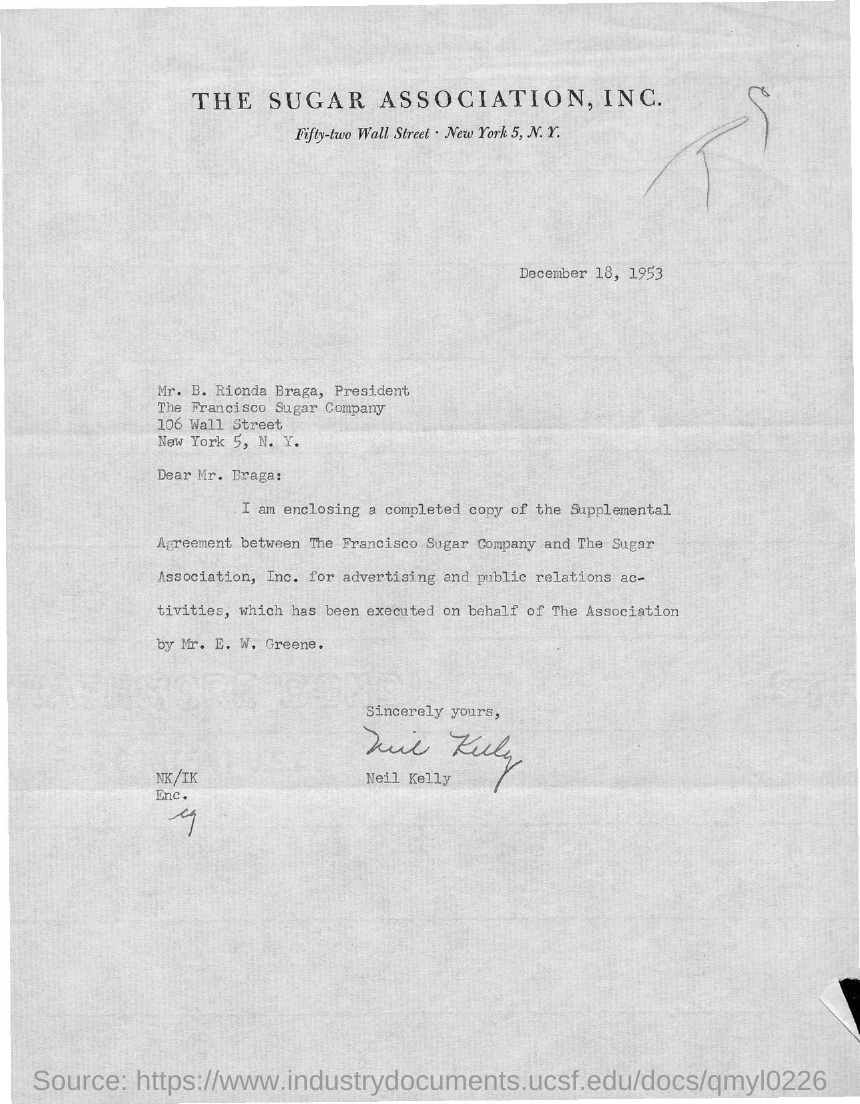Outline some significant characteristics in this image. It is clear that the sender is Neil Kelly based on the information provided. To whom is the letter addressed? The letter is addressed to Mr. Braga. The document is dated December 18, 1953. The Sugar Association, Inc. is mentioned. The president of The Francisco Sugar Company is Mr. Braga. 